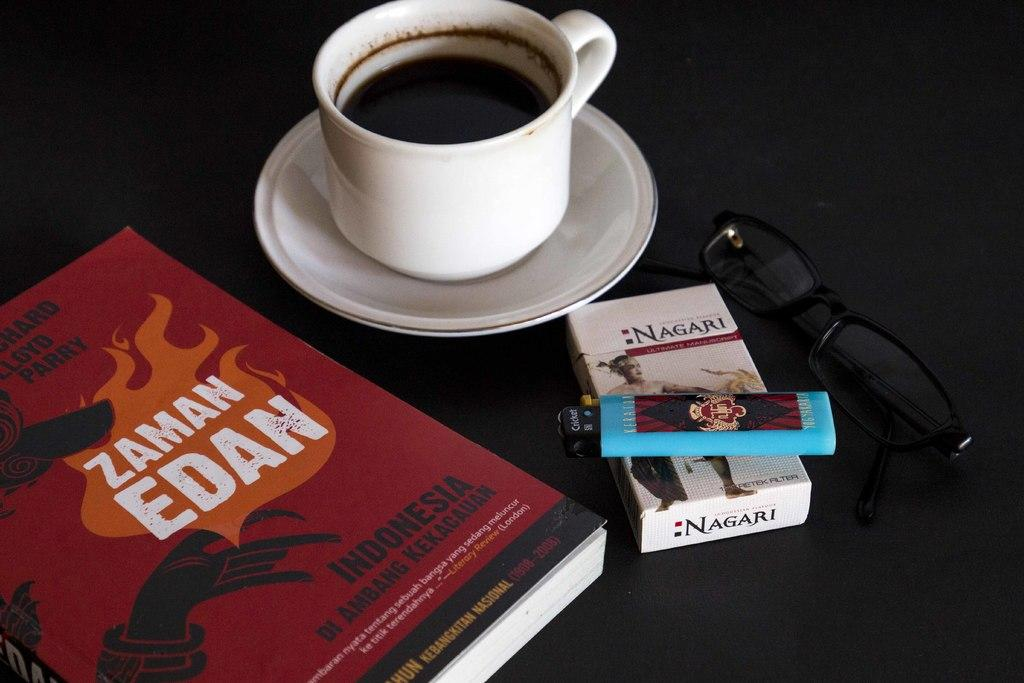<image>
Create a compact narrative representing the image presented. A cup of coffe sits on a table next to sunglasses, Nagari cigarettes , a lighter and a book by Zaman Edan. 